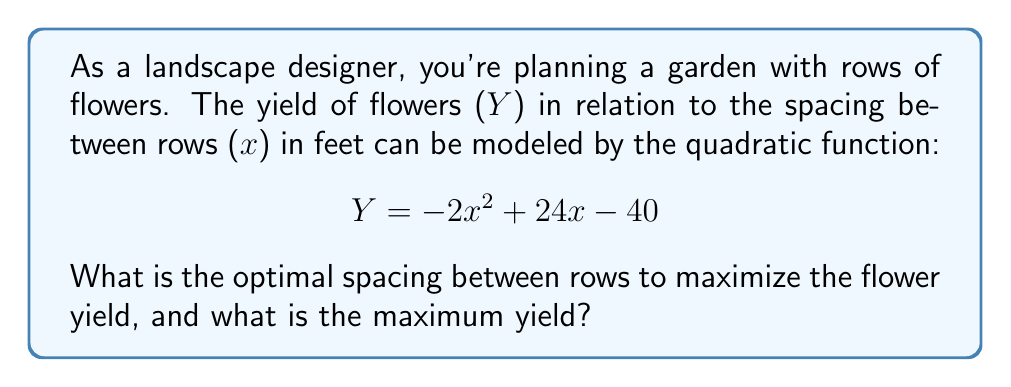Could you help me with this problem? To solve this problem, we'll follow these steps:

1) The given quadratic function is in the form $Y = ax^2 + bx + c$, where:
   $a = -2$, $b = 24$, and $c = -40$

2) For a quadratic function, the x-coordinate of the vertex represents the optimal input (in this case, the optimal spacing), and the y-coordinate represents the maximum output (the maximum yield).

3) To find the x-coordinate of the vertex, we use the formula: $x = -\frac{b}{2a}$

   $x = -\frac{24}{2(-2)} = -\frac{24}{-4} = 6$

4) To find the maximum yield (y-coordinate of the vertex), we substitute x = 6 into the original function:

   $Y = -2(6)^2 + 24(6) - 40$
   $= -2(36) + 144 - 40$
   $= -72 + 144 - 40$
   $= 32$

5) We can verify this is a maximum (not a minimum) because $a < 0$ in the original function, meaning the parabola opens downward.

[asy]
import graph;
size(200,200);
real f(real x) {return -2x^2+24x-40;}
xaxis("x",arrow=Arrow);
yaxis("y",arrow=Arrow);
draw(graph(f,-1,13));
dot((6,32));
label("(6,32)",(6,32),NE);
[/asy]
Answer: The optimal spacing between rows is 6 feet, and the maximum yield is 32 units. 